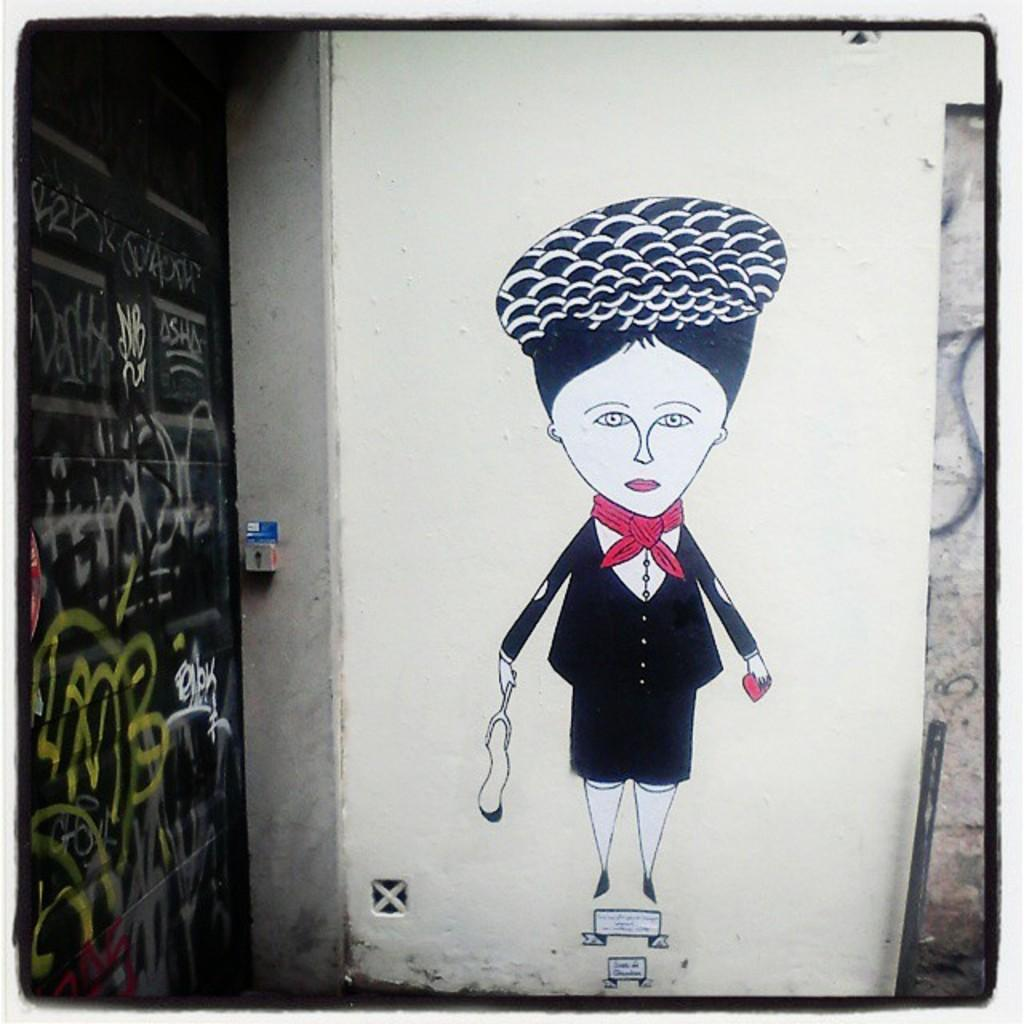What is present on the wall in the picture? There is a painting of a cartoon woman standing on the wall. How many walls are visible in the image? There are two walls visible in the image. Can you describe the second wall? The second wall is black in color and has some scribbling on it. What type of dock can be seen near the cemetery in the image? There is no dock or cemetery present in the image; it only features two walls with a painting and some scribbling. 